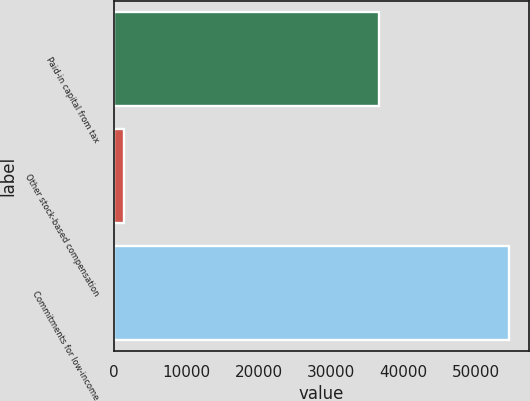<chart> <loc_0><loc_0><loc_500><loc_500><bar_chart><fcel>Paid-in capital from tax<fcel>Other stock-based compensation<fcel>Commitments for low-income<nl><fcel>36545<fcel>1375<fcel>54549<nl></chart> 